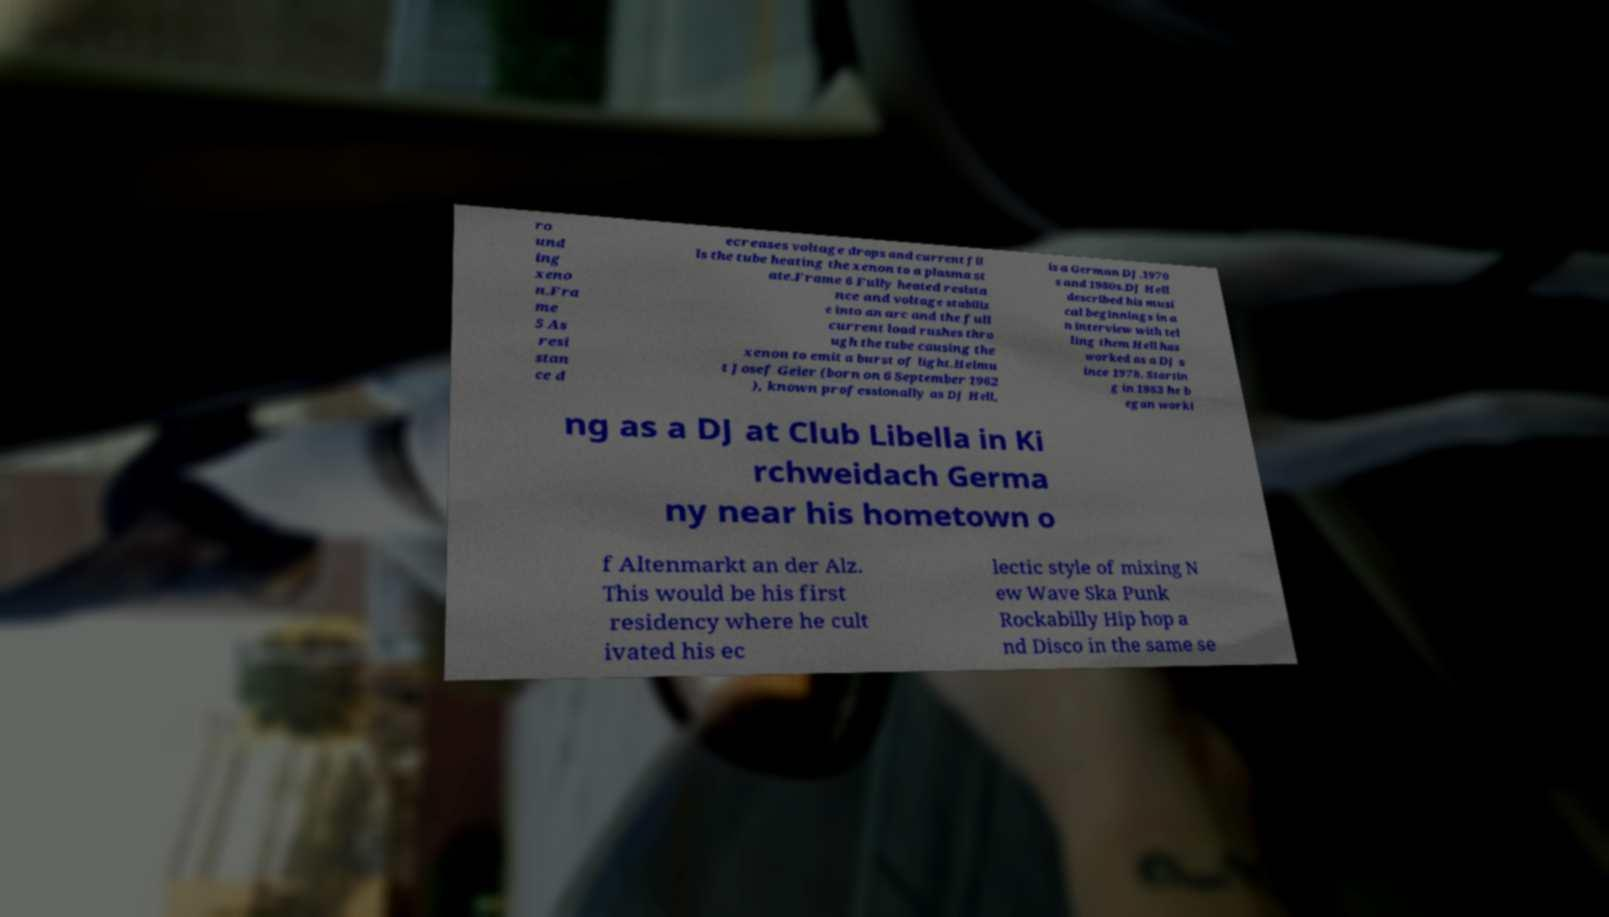Could you assist in decoding the text presented in this image and type it out clearly? ro und ing xeno n.Fra me 5 As resi stan ce d ecreases voltage drops and current fil ls the tube heating the xenon to a plasma st ate.Frame 6 Fully heated resista nce and voltage stabiliz e into an arc and the full current load rushes thro ugh the tube causing the xenon to emit a burst of light.Helmu t Josef Geier (born on 6 September 1962 ), known professionally as DJ Hell, is a German DJ.1970 s and 1980s.DJ Hell described his musi cal beginnings in a n interview with tel ling them Hell has worked as a DJ s ince 1978. Startin g in 1983 he b egan worki ng as a DJ at Club Libella in Ki rchweidach Germa ny near his hometown o f Altenmarkt an der Alz. This would be his first residency where he cult ivated his ec lectic style of mixing N ew Wave Ska Punk Rockabilly Hip hop a nd Disco in the same se 